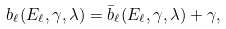<formula> <loc_0><loc_0><loc_500><loc_500>b _ { \ell } ( E _ { \ell } , \gamma , \lambda ) = { \bar { b } } _ { \ell } ( E _ { \ell } , \gamma , \lambda ) + \gamma ,</formula> 